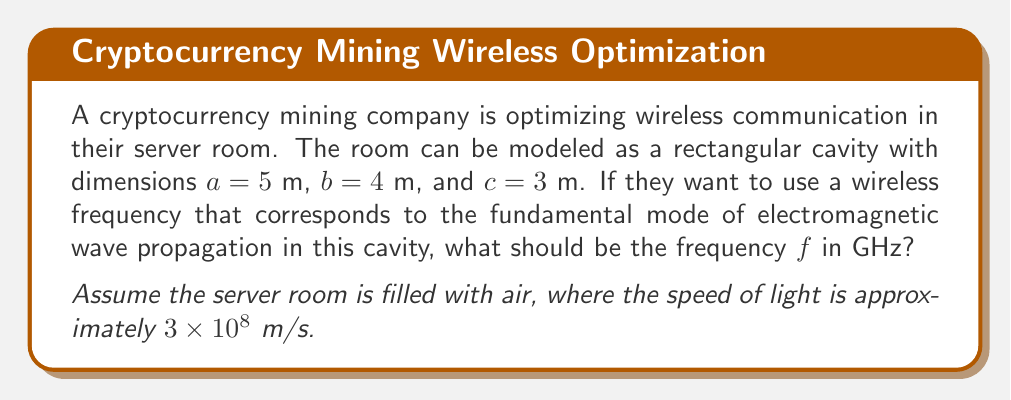Can you answer this question? To solve this problem, we'll follow these steps:

1) The wave equation for electromagnetic waves in a rectangular cavity is given by:

   $$\frac{\partial^2 E}{\partial x^2} + \frac{\partial^2 E}{\partial y^2} + \frac{\partial^2 E}{\partial z^2} = \frac{1}{c^2}\frac{\partial^2 E}{\partial t^2}$$

2) The solution for the electric field in a rectangular cavity is:

   $$E_{xyz} = E_0 \sin(\frac{m\pi x}{a}) \sin(\frac{n\pi y}{b}) \sin(\frac{p\pi z}{c}) \cos(\omega t)$$

   where $m$, $n$, and $p$ are integers representing the mode numbers.

3) The resonant frequency for a given mode $(m,n,p)$ is:

   $$f_{mnp} = \frac{c}{2} \sqrt{(\frac{m}{a})^2 + (\frac{n}{b})^2 + (\frac{p}{c})^2}$$

4) The fundamental mode corresponds to the lowest possible frequency, which occurs when $m=1$, $n=1$, and $p=1$.

5) Substituting these values and the given dimensions:

   $$f_{111} = \frac{3 \times 10^8}{2} \sqrt{(\frac{1}{5})^2 + (\frac{1}{4})^2 + (\frac{1}{3})^2}$$

6) Simplifying:

   $$f_{111} = 1.5 \times 10^8 \sqrt{0.04 + 0.0625 + 0.1111}$$
   $$f_{111} = 1.5 \times 10^8 \sqrt{0.2136}$$
   $$f_{111} = 1.5 \times 10^8 \times 0.4622$$
   $$f_{111} = 69.33 \times 10^6 \text{ Hz} = 69.33 \text{ MHz}$$

7) Converting to GHz:

   $$f_{111} = 0.06933 \text{ GHz}$$
Answer: $0.06933$ GHz 